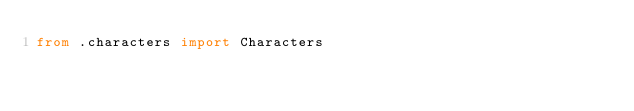<code> <loc_0><loc_0><loc_500><loc_500><_Python_>from .characters import Characters
</code> 